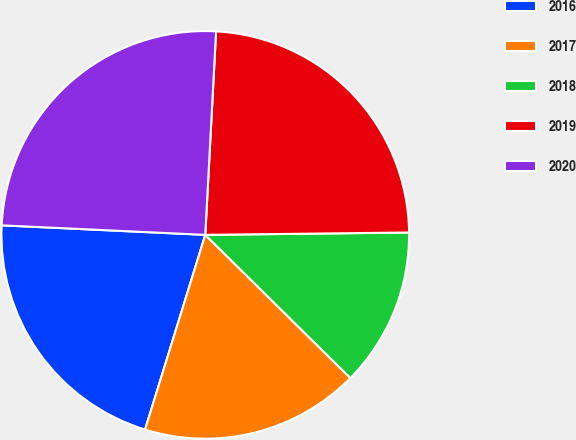Convert chart. <chart><loc_0><loc_0><loc_500><loc_500><pie_chart><fcel>2016<fcel>2017<fcel>2018<fcel>2019<fcel>2020<nl><fcel>20.97%<fcel>17.38%<fcel>12.58%<fcel>23.97%<fcel>25.1%<nl></chart> 